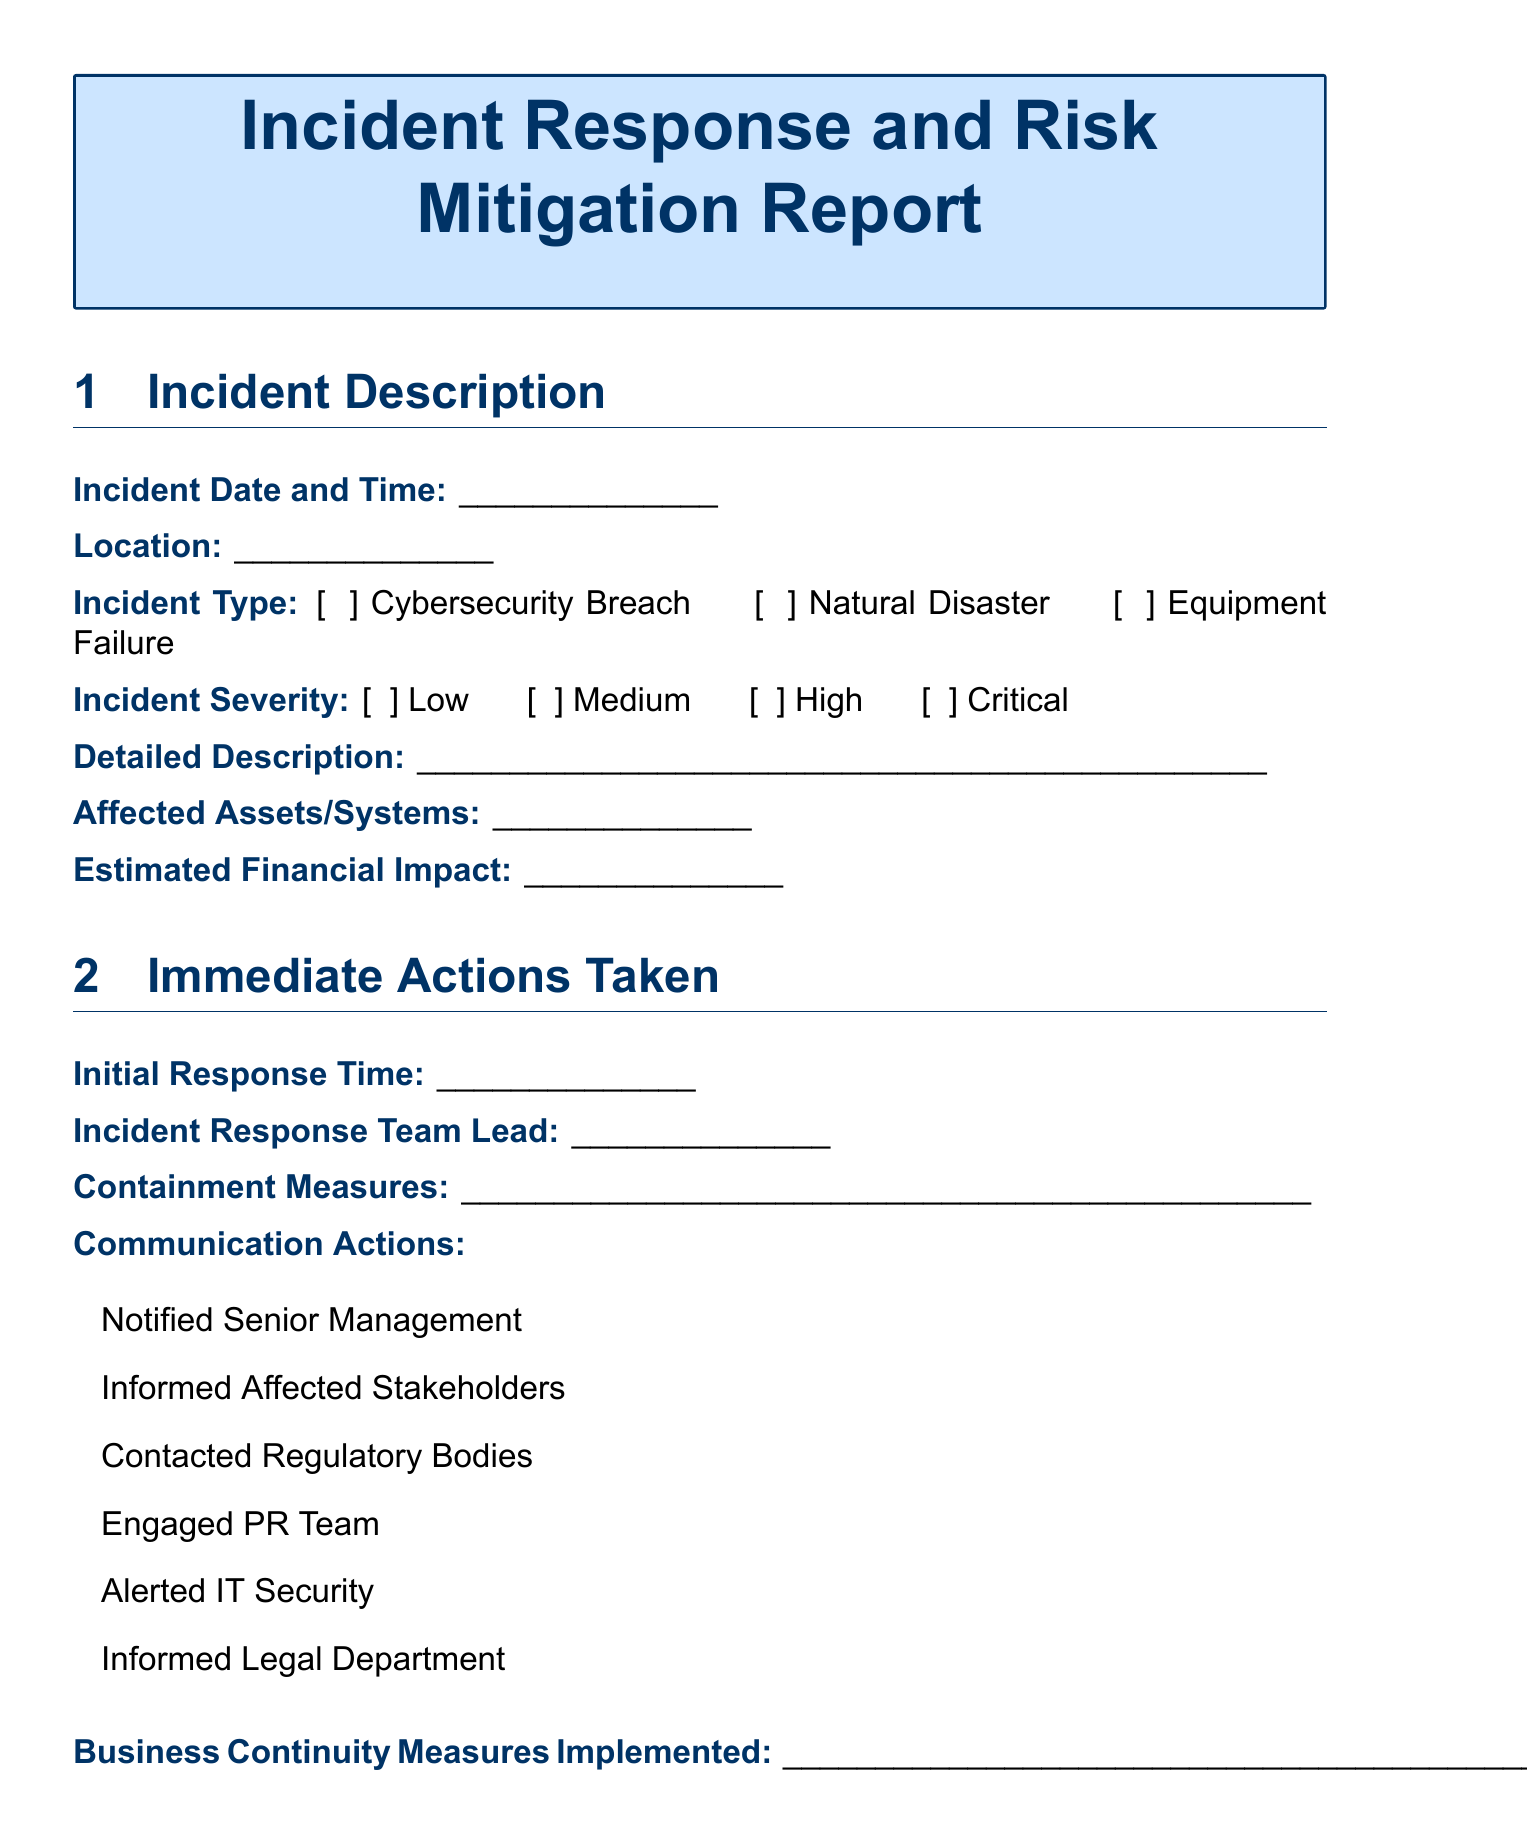What is the incident date and time? The incident date and time is recorded in the "Incident Date and Time" field of the document.
Answer: ___________ What is the incident type? The incident type is listed in the "Incident Type" section, which is a dropdown with predefined options.
Answer: Cybersecurity Breach, Natural Disaster, Equipment Failure, Human Error, Regulatory Non-Compliance, Supply Chain Disruption, Financial Loss, Reputational Damage, Other (Please Specify) What actions were taken to contain the incident? The containment measures are detailed in the "Containment Measures" field of the document.
Answer: ___________ Who is the Incident Response Team Lead? The name of the Incident Response Team Lead is noted in the "Incident Response Team Lead" field.
Answer: ___________ What was identified as the primary cause of the incident? The primary cause is noted in the "Primary Cause" field in the Root Cause Analysis section.
Answer: ___________ What financial impact is estimated from the incident? The estimated financial impact is entered in the "Estimated Financial Impact" field.
Answer: ___________ Which training requirements are needed? Training requirements are outlined in the "Training Requirements" section with several checkbox options.
Answer: Employee Awareness Program, Technical Skills Enhancement, Incident Response Drills, Compliance Training, Vendor Management Training What is the date of the report? The report date is found in the "Date of Report" field.
Answer: ___________ What are the proposed policy changes? Proposed policy changes are noted in the "Proposed Policy Changes" field of the document.
Answer: ___________ What follow-up review date has been established? The follow-up review date is noted in the "Follow-up Review Date" field.
Answer: ___________ 